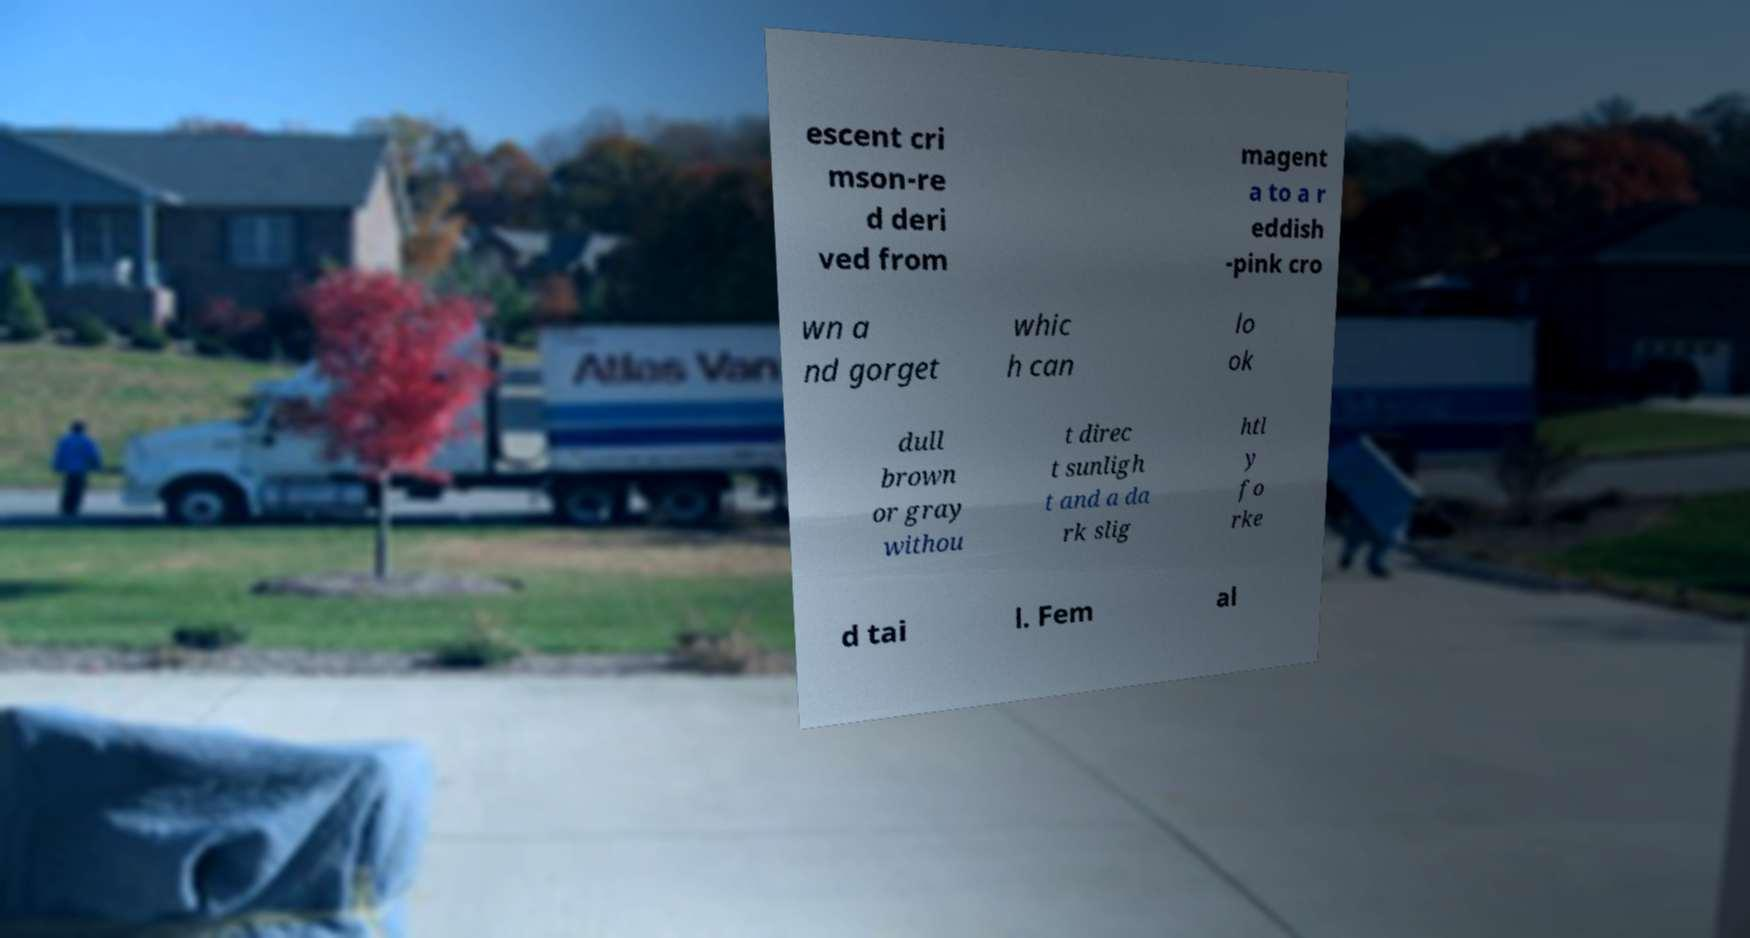Can you read and provide the text displayed in the image?This photo seems to have some interesting text. Can you extract and type it out for me? escent cri mson-re d deri ved from magent a to a r eddish -pink cro wn a nd gorget whic h can lo ok dull brown or gray withou t direc t sunligh t and a da rk slig htl y fo rke d tai l. Fem al 